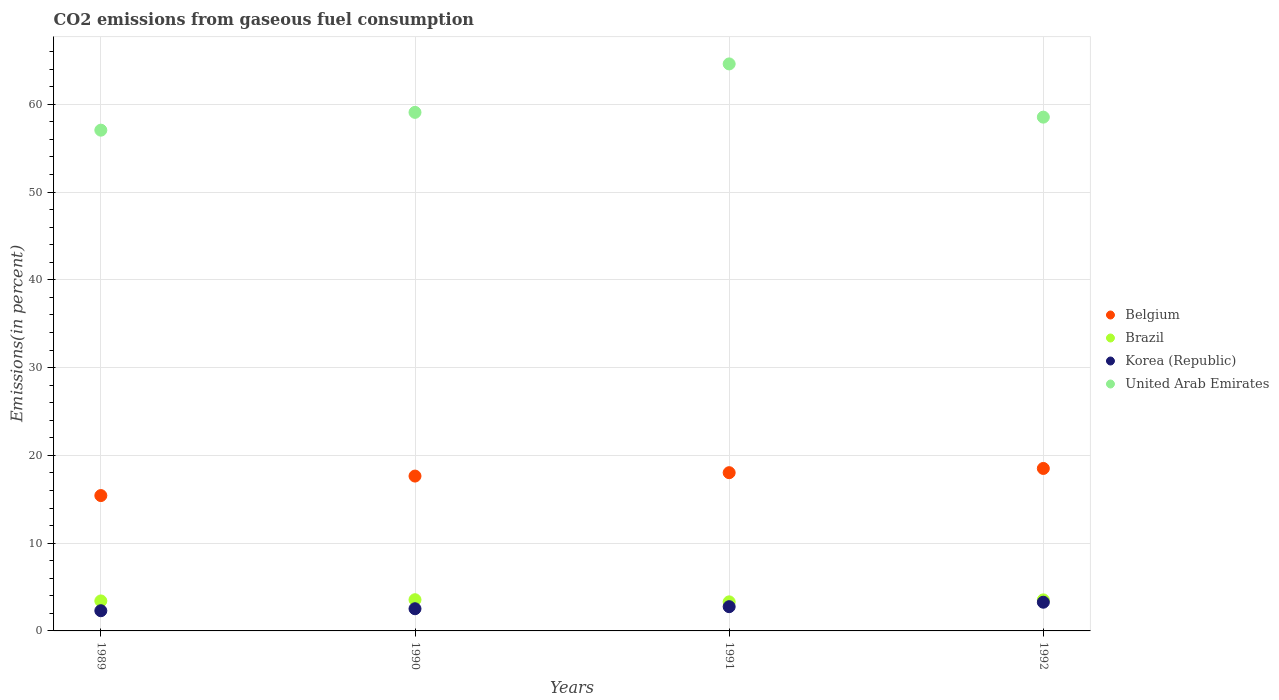How many different coloured dotlines are there?
Your answer should be compact. 4. Is the number of dotlines equal to the number of legend labels?
Offer a very short reply. Yes. What is the total CO2 emitted in United Arab Emirates in 1991?
Give a very brief answer. 64.6. Across all years, what is the maximum total CO2 emitted in Korea (Republic)?
Give a very brief answer. 3.27. Across all years, what is the minimum total CO2 emitted in Brazil?
Ensure brevity in your answer.  3.31. What is the total total CO2 emitted in Brazil in the graph?
Provide a succinct answer. 13.82. What is the difference between the total CO2 emitted in Korea (Republic) in 1990 and that in 1991?
Offer a very short reply. -0.23. What is the difference between the total CO2 emitted in United Arab Emirates in 1991 and the total CO2 emitted in Brazil in 1989?
Offer a very short reply. 61.18. What is the average total CO2 emitted in Brazil per year?
Offer a terse response. 3.45. In the year 1991, what is the difference between the total CO2 emitted in Brazil and total CO2 emitted in Belgium?
Keep it short and to the point. -14.72. What is the ratio of the total CO2 emitted in Brazil in 1990 to that in 1991?
Your response must be concise. 1.07. Is the total CO2 emitted in Belgium in 1990 less than that in 1991?
Offer a terse response. Yes. Is the difference between the total CO2 emitted in Brazil in 1989 and 1991 greater than the difference between the total CO2 emitted in Belgium in 1989 and 1991?
Make the answer very short. Yes. What is the difference between the highest and the second highest total CO2 emitted in Belgium?
Provide a short and direct response. 0.48. What is the difference between the highest and the lowest total CO2 emitted in Brazil?
Provide a short and direct response. 0.24. In how many years, is the total CO2 emitted in United Arab Emirates greater than the average total CO2 emitted in United Arab Emirates taken over all years?
Your answer should be very brief. 1. Is the sum of the total CO2 emitted in United Arab Emirates in 1991 and 1992 greater than the maximum total CO2 emitted in Belgium across all years?
Offer a terse response. Yes. Is it the case that in every year, the sum of the total CO2 emitted in Korea (Republic) and total CO2 emitted in Belgium  is greater than the sum of total CO2 emitted in United Arab Emirates and total CO2 emitted in Brazil?
Offer a terse response. No. Is the total CO2 emitted in Belgium strictly greater than the total CO2 emitted in Brazil over the years?
Offer a very short reply. Yes. How many years are there in the graph?
Your answer should be very brief. 4. Are the values on the major ticks of Y-axis written in scientific E-notation?
Provide a short and direct response. No. Where does the legend appear in the graph?
Make the answer very short. Center right. How many legend labels are there?
Offer a terse response. 4. How are the legend labels stacked?
Give a very brief answer. Vertical. What is the title of the graph?
Your response must be concise. CO2 emissions from gaseous fuel consumption. Does "Bulgaria" appear as one of the legend labels in the graph?
Your answer should be very brief. No. What is the label or title of the Y-axis?
Offer a terse response. Emissions(in percent). What is the Emissions(in percent) in Belgium in 1989?
Offer a very short reply. 15.42. What is the Emissions(in percent) of Brazil in 1989?
Your answer should be compact. 3.42. What is the Emissions(in percent) in Korea (Republic) in 1989?
Provide a succinct answer. 2.3. What is the Emissions(in percent) in United Arab Emirates in 1989?
Ensure brevity in your answer.  57.05. What is the Emissions(in percent) in Belgium in 1990?
Your answer should be very brief. 17.64. What is the Emissions(in percent) in Brazil in 1990?
Your answer should be compact. 3.55. What is the Emissions(in percent) in Korea (Republic) in 1990?
Your answer should be compact. 2.53. What is the Emissions(in percent) in United Arab Emirates in 1990?
Offer a very short reply. 59.08. What is the Emissions(in percent) of Belgium in 1991?
Your response must be concise. 18.03. What is the Emissions(in percent) of Brazil in 1991?
Your answer should be very brief. 3.31. What is the Emissions(in percent) in Korea (Republic) in 1991?
Keep it short and to the point. 2.76. What is the Emissions(in percent) of United Arab Emirates in 1991?
Your response must be concise. 64.6. What is the Emissions(in percent) in Belgium in 1992?
Provide a short and direct response. 18.51. What is the Emissions(in percent) of Brazil in 1992?
Keep it short and to the point. 3.54. What is the Emissions(in percent) in Korea (Republic) in 1992?
Offer a terse response. 3.27. What is the Emissions(in percent) of United Arab Emirates in 1992?
Provide a succinct answer. 58.53. Across all years, what is the maximum Emissions(in percent) in Belgium?
Give a very brief answer. 18.51. Across all years, what is the maximum Emissions(in percent) in Brazil?
Your response must be concise. 3.55. Across all years, what is the maximum Emissions(in percent) in Korea (Republic)?
Offer a terse response. 3.27. Across all years, what is the maximum Emissions(in percent) of United Arab Emirates?
Keep it short and to the point. 64.6. Across all years, what is the minimum Emissions(in percent) in Belgium?
Your answer should be compact. 15.42. Across all years, what is the minimum Emissions(in percent) of Brazil?
Keep it short and to the point. 3.31. Across all years, what is the minimum Emissions(in percent) of Korea (Republic)?
Your response must be concise. 2.3. Across all years, what is the minimum Emissions(in percent) in United Arab Emirates?
Give a very brief answer. 57.05. What is the total Emissions(in percent) in Belgium in the graph?
Give a very brief answer. 69.6. What is the total Emissions(in percent) in Brazil in the graph?
Ensure brevity in your answer.  13.82. What is the total Emissions(in percent) of Korea (Republic) in the graph?
Your response must be concise. 10.86. What is the total Emissions(in percent) in United Arab Emirates in the graph?
Your response must be concise. 239.26. What is the difference between the Emissions(in percent) in Belgium in 1989 and that in 1990?
Provide a short and direct response. -2.22. What is the difference between the Emissions(in percent) in Brazil in 1989 and that in 1990?
Make the answer very short. -0.14. What is the difference between the Emissions(in percent) of Korea (Republic) in 1989 and that in 1990?
Your answer should be compact. -0.23. What is the difference between the Emissions(in percent) in United Arab Emirates in 1989 and that in 1990?
Give a very brief answer. -2.03. What is the difference between the Emissions(in percent) in Belgium in 1989 and that in 1991?
Your answer should be compact. -2.61. What is the difference between the Emissions(in percent) of Brazil in 1989 and that in 1991?
Your answer should be very brief. 0.1. What is the difference between the Emissions(in percent) in Korea (Republic) in 1989 and that in 1991?
Provide a short and direct response. -0.46. What is the difference between the Emissions(in percent) in United Arab Emirates in 1989 and that in 1991?
Ensure brevity in your answer.  -7.55. What is the difference between the Emissions(in percent) of Belgium in 1989 and that in 1992?
Your answer should be compact. -3.09. What is the difference between the Emissions(in percent) of Brazil in 1989 and that in 1992?
Your answer should be compact. -0.12. What is the difference between the Emissions(in percent) of Korea (Republic) in 1989 and that in 1992?
Offer a terse response. -0.97. What is the difference between the Emissions(in percent) in United Arab Emirates in 1989 and that in 1992?
Provide a succinct answer. -1.48. What is the difference between the Emissions(in percent) in Belgium in 1990 and that in 1991?
Give a very brief answer. -0.39. What is the difference between the Emissions(in percent) of Brazil in 1990 and that in 1991?
Offer a very short reply. 0.24. What is the difference between the Emissions(in percent) in Korea (Republic) in 1990 and that in 1991?
Ensure brevity in your answer.  -0.23. What is the difference between the Emissions(in percent) in United Arab Emirates in 1990 and that in 1991?
Your answer should be compact. -5.52. What is the difference between the Emissions(in percent) of Belgium in 1990 and that in 1992?
Give a very brief answer. -0.87. What is the difference between the Emissions(in percent) of Brazil in 1990 and that in 1992?
Make the answer very short. 0.02. What is the difference between the Emissions(in percent) in Korea (Republic) in 1990 and that in 1992?
Provide a succinct answer. -0.74. What is the difference between the Emissions(in percent) of United Arab Emirates in 1990 and that in 1992?
Offer a very short reply. 0.54. What is the difference between the Emissions(in percent) of Belgium in 1991 and that in 1992?
Offer a terse response. -0.48. What is the difference between the Emissions(in percent) in Brazil in 1991 and that in 1992?
Your response must be concise. -0.22. What is the difference between the Emissions(in percent) in Korea (Republic) in 1991 and that in 1992?
Your response must be concise. -0.51. What is the difference between the Emissions(in percent) of United Arab Emirates in 1991 and that in 1992?
Your answer should be very brief. 6.06. What is the difference between the Emissions(in percent) of Belgium in 1989 and the Emissions(in percent) of Brazil in 1990?
Offer a terse response. 11.87. What is the difference between the Emissions(in percent) of Belgium in 1989 and the Emissions(in percent) of Korea (Republic) in 1990?
Ensure brevity in your answer.  12.89. What is the difference between the Emissions(in percent) of Belgium in 1989 and the Emissions(in percent) of United Arab Emirates in 1990?
Provide a succinct answer. -43.66. What is the difference between the Emissions(in percent) in Brazil in 1989 and the Emissions(in percent) in Korea (Republic) in 1990?
Provide a short and direct response. 0.89. What is the difference between the Emissions(in percent) of Brazil in 1989 and the Emissions(in percent) of United Arab Emirates in 1990?
Ensure brevity in your answer.  -55.66. What is the difference between the Emissions(in percent) in Korea (Republic) in 1989 and the Emissions(in percent) in United Arab Emirates in 1990?
Provide a succinct answer. -56.78. What is the difference between the Emissions(in percent) of Belgium in 1989 and the Emissions(in percent) of Brazil in 1991?
Ensure brevity in your answer.  12.11. What is the difference between the Emissions(in percent) of Belgium in 1989 and the Emissions(in percent) of Korea (Republic) in 1991?
Your answer should be very brief. 12.66. What is the difference between the Emissions(in percent) of Belgium in 1989 and the Emissions(in percent) of United Arab Emirates in 1991?
Offer a very short reply. -49.18. What is the difference between the Emissions(in percent) in Brazil in 1989 and the Emissions(in percent) in Korea (Republic) in 1991?
Your response must be concise. 0.66. What is the difference between the Emissions(in percent) in Brazil in 1989 and the Emissions(in percent) in United Arab Emirates in 1991?
Provide a short and direct response. -61.18. What is the difference between the Emissions(in percent) in Korea (Republic) in 1989 and the Emissions(in percent) in United Arab Emirates in 1991?
Keep it short and to the point. -62.3. What is the difference between the Emissions(in percent) of Belgium in 1989 and the Emissions(in percent) of Brazil in 1992?
Ensure brevity in your answer.  11.88. What is the difference between the Emissions(in percent) in Belgium in 1989 and the Emissions(in percent) in Korea (Republic) in 1992?
Offer a very short reply. 12.15. What is the difference between the Emissions(in percent) of Belgium in 1989 and the Emissions(in percent) of United Arab Emirates in 1992?
Keep it short and to the point. -43.11. What is the difference between the Emissions(in percent) of Brazil in 1989 and the Emissions(in percent) of Korea (Republic) in 1992?
Offer a terse response. 0.15. What is the difference between the Emissions(in percent) of Brazil in 1989 and the Emissions(in percent) of United Arab Emirates in 1992?
Give a very brief answer. -55.12. What is the difference between the Emissions(in percent) in Korea (Republic) in 1989 and the Emissions(in percent) in United Arab Emirates in 1992?
Keep it short and to the point. -56.23. What is the difference between the Emissions(in percent) of Belgium in 1990 and the Emissions(in percent) of Brazil in 1991?
Your answer should be very brief. 14.33. What is the difference between the Emissions(in percent) of Belgium in 1990 and the Emissions(in percent) of Korea (Republic) in 1991?
Provide a short and direct response. 14.88. What is the difference between the Emissions(in percent) in Belgium in 1990 and the Emissions(in percent) in United Arab Emirates in 1991?
Provide a succinct answer. -46.96. What is the difference between the Emissions(in percent) in Brazil in 1990 and the Emissions(in percent) in Korea (Republic) in 1991?
Make the answer very short. 0.79. What is the difference between the Emissions(in percent) of Brazil in 1990 and the Emissions(in percent) of United Arab Emirates in 1991?
Make the answer very short. -61.04. What is the difference between the Emissions(in percent) in Korea (Republic) in 1990 and the Emissions(in percent) in United Arab Emirates in 1991?
Offer a terse response. -62.07. What is the difference between the Emissions(in percent) in Belgium in 1990 and the Emissions(in percent) in Brazil in 1992?
Your answer should be compact. 14.11. What is the difference between the Emissions(in percent) of Belgium in 1990 and the Emissions(in percent) of Korea (Republic) in 1992?
Offer a very short reply. 14.37. What is the difference between the Emissions(in percent) of Belgium in 1990 and the Emissions(in percent) of United Arab Emirates in 1992?
Your answer should be compact. -40.89. What is the difference between the Emissions(in percent) in Brazil in 1990 and the Emissions(in percent) in Korea (Republic) in 1992?
Provide a short and direct response. 0.28. What is the difference between the Emissions(in percent) in Brazil in 1990 and the Emissions(in percent) in United Arab Emirates in 1992?
Provide a short and direct response. -54.98. What is the difference between the Emissions(in percent) in Korea (Republic) in 1990 and the Emissions(in percent) in United Arab Emirates in 1992?
Offer a very short reply. -56.01. What is the difference between the Emissions(in percent) in Belgium in 1991 and the Emissions(in percent) in Brazil in 1992?
Your answer should be very brief. 14.49. What is the difference between the Emissions(in percent) in Belgium in 1991 and the Emissions(in percent) in Korea (Republic) in 1992?
Your response must be concise. 14.76. What is the difference between the Emissions(in percent) in Belgium in 1991 and the Emissions(in percent) in United Arab Emirates in 1992?
Make the answer very short. -40.51. What is the difference between the Emissions(in percent) of Brazil in 1991 and the Emissions(in percent) of Korea (Republic) in 1992?
Your response must be concise. 0.04. What is the difference between the Emissions(in percent) in Brazil in 1991 and the Emissions(in percent) in United Arab Emirates in 1992?
Your answer should be very brief. -55.22. What is the difference between the Emissions(in percent) in Korea (Republic) in 1991 and the Emissions(in percent) in United Arab Emirates in 1992?
Your answer should be very brief. -55.77. What is the average Emissions(in percent) of Belgium per year?
Provide a succinct answer. 17.4. What is the average Emissions(in percent) of Brazil per year?
Provide a short and direct response. 3.45. What is the average Emissions(in percent) in Korea (Republic) per year?
Your response must be concise. 2.71. What is the average Emissions(in percent) of United Arab Emirates per year?
Your answer should be very brief. 59.81. In the year 1989, what is the difference between the Emissions(in percent) in Belgium and Emissions(in percent) in Brazil?
Make the answer very short. 12. In the year 1989, what is the difference between the Emissions(in percent) in Belgium and Emissions(in percent) in Korea (Republic)?
Your answer should be compact. 13.12. In the year 1989, what is the difference between the Emissions(in percent) in Belgium and Emissions(in percent) in United Arab Emirates?
Provide a succinct answer. -41.63. In the year 1989, what is the difference between the Emissions(in percent) in Brazil and Emissions(in percent) in Korea (Republic)?
Give a very brief answer. 1.12. In the year 1989, what is the difference between the Emissions(in percent) of Brazil and Emissions(in percent) of United Arab Emirates?
Offer a very short reply. -53.63. In the year 1989, what is the difference between the Emissions(in percent) in Korea (Republic) and Emissions(in percent) in United Arab Emirates?
Make the answer very short. -54.75. In the year 1990, what is the difference between the Emissions(in percent) of Belgium and Emissions(in percent) of Brazil?
Provide a short and direct response. 14.09. In the year 1990, what is the difference between the Emissions(in percent) of Belgium and Emissions(in percent) of Korea (Republic)?
Provide a succinct answer. 15.11. In the year 1990, what is the difference between the Emissions(in percent) of Belgium and Emissions(in percent) of United Arab Emirates?
Your answer should be compact. -41.44. In the year 1990, what is the difference between the Emissions(in percent) of Brazil and Emissions(in percent) of Korea (Republic)?
Provide a succinct answer. 1.03. In the year 1990, what is the difference between the Emissions(in percent) in Brazil and Emissions(in percent) in United Arab Emirates?
Give a very brief answer. -55.52. In the year 1990, what is the difference between the Emissions(in percent) of Korea (Republic) and Emissions(in percent) of United Arab Emirates?
Offer a terse response. -56.55. In the year 1991, what is the difference between the Emissions(in percent) of Belgium and Emissions(in percent) of Brazil?
Your answer should be compact. 14.72. In the year 1991, what is the difference between the Emissions(in percent) of Belgium and Emissions(in percent) of Korea (Republic)?
Keep it short and to the point. 15.27. In the year 1991, what is the difference between the Emissions(in percent) in Belgium and Emissions(in percent) in United Arab Emirates?
Give a very brief answer. -46.57. In the year 1991, what is the difference between the Emissions(in percent) of Brazil and Emissions(in percent) of Korea (Republic)?
Make the answer very short. 0.55. In the year 1991, what is the difference between the Emissions(in percent) of Brazil and Emissions(in percent) of United Arab Emirates?
Make the answer very short. -61.29. In the year 1991, what is the difference between the Emissions(in percent) in Korea (Republic) and Emissions(in percent) in United Arab Emirates?
Offer a very short reply. -61.84. In the year 1992, what is the difference between the Emissions(in percent) of Belgium and Emissions(in percent) of Brazil?
Make the answer very short. 14.97. In the year 1992, what is the difference between the Emissions(in percent) in Belgium and Emissions(in percent) in Korea (Republic)?
Provide a succinct answer. 15.24. In the year 1992, what is the difference between the Emissions(in percent) in Belgium and Emissions(in percent) in United Arab Emirates?
Offer a very short reply. -40.02. In the year 1992, what is the difference between the Emissions(in percent) in Brazil and Emissions(in percent) in Korea (Republic)?
Keep it short and to the point. 0.27. In the year 1992, what is the difference between the Emissions(in percent) in Brazil and Emissions(in percent) in United Arab Emirates?
Give a very brief answer. -55. In the year 1992, what is the difference between the Emissions(in percent) in Korea (Republic) and Emissions(in percent) in United Arab Emirates?
Keep it short and to the point. -55.26. What is the ratio of the Emissions(in percent) in Belgium in 1989 to that in 1990?
Provide a short and direct response. 0.87. What is the ratio of the Emissions(in percent) of Brazil in 1989 to that in 1990?
Give a very brief answer. 0.96. What is the ratio of the Emissions(in percent) of Korea (Republic) in 1989 to that in 1990?
Make the answer very short. 0.91. What is the ratio of the Emissions(in percent) of United Arab Emirates in 1989 to that in 1990?
Ensure brevity in your answer.  0.97. What is the ratio of the Emissions(in percent) of Belgium in 1989 to that in 1991?
Make the answer very short. 0.86. What is the ratio of the Emissions(in percent) of Brazil in 1989 to that in 1991?
Your response must be concise. 1.03. What is the ratio of the Emissions(in percent) in Korea (Republic) in 1989 to that in 1991?
Give a very brief answer. 0.83. What is the ratio of the Emissions(in percent) in United Arab Emirates in 1989 to that in 1991?
Make the answer very short. 0.88. What is the ratio of the Emissions(in percent) of Belgium in 1989 to that in 1992?
Ensure brevity in your answer.  0.83. What is the ratio of the Emissions(in percent) of Brazil in 1989 to that in 1992?
Give a very brief answer. 0.97. What is the ratio of the Emissions(in percent) in Korea (Republic) in 1989 to that in 1992?
Provide a short and direct response. 0.7. What is the ratio of the Emissions(in percent) of United Arab Emirates in 1989 to that in 1992?
Offer a very short reply. 0.97. What is the ratio of the Emissions(in percent) in Belgium in 1990 to that in 1991?
Keep it short and to the point. 0.98. What is the ratio of the Emissions(in percent) of Brazil in 1990 to that in 1991?
Make the answer very short. 1.07. What is the ratio of the Emissions(in percent) of Korea (Republic) in 1990 to that in 1991?
Offer a terse response. 0.92. What is the ratio of the Emissions(in percent) of United Arab Emirates in 1990 to that in 1991?
Ensure brevity in your answer.  0.91. What is the ratio of the Emissions(in percent) in Belgium in 1990 to that in 1992?
Make the answer very short. 0.95. What is the ratio of the Emissions(in percent) in Brazil in 1990 to that in 1992?
Keep it short and to the point. 1.01. What is the ratio of the Emissions(in percent) of Korea (Republic) in 1990 to that in 1992?
Your answer should be compact. 0.77. What is the ratio of the Emissions(in percent) of United Arab Emirates in 1990 to that in 1992?
Make the answer very short. 1.01. What is the ratio of the Emissions(in percent) in Belgium in 1991 to that in 1992?
Provide a succinct answer. 0.97. What is the ratio of the Emissions(in percent) in Brazil in 1991 to that in 1992?
Make the answer very short. 0.94. What is the ratio of the Emissions(in percent) of Korea (Republic) in 1991 to that in 1992?
Your response must be concise. 0.84. What is the ratio of the Emissions(in percent) in United Arab Emirates in 1991 to that in 1992?
Provide a short and direct response. 1.1. What is the difference between the highest and the second highest Emissions(in percent) of Belgium?
Your answer should be compact. 0.48. What is the difference between the highest and the second highest Emissions(in percent) of Brazil?
Provide a succinct answer. 0.02. What is the difference between the highest and the second highest Emissions(in percent) in Korea (Republic)?
Ensure brevity in your answer.  0.51. What is the difference between the highest and the second highest Emissions(in percent) of United Arab Emirates?
Provide a succinct answer. 5.52. What is the difference between the highest and the lowest Emissions(in percent) in Belgium?
Your answer should be compact. 3.09. What is the difference between the highest and the lowest Emissions(in percent) of Brazil?
Offer a very short reply. 0.24. What is the difference between the highest and the lowest Emissions(in percent) of Korea (Republic)?
Your answer should be compact. 0.97. What is the difference between the highest and the lowest Emissions(in percent) in United Arab Emirates?
Provide a succinct answer. 7.55. 